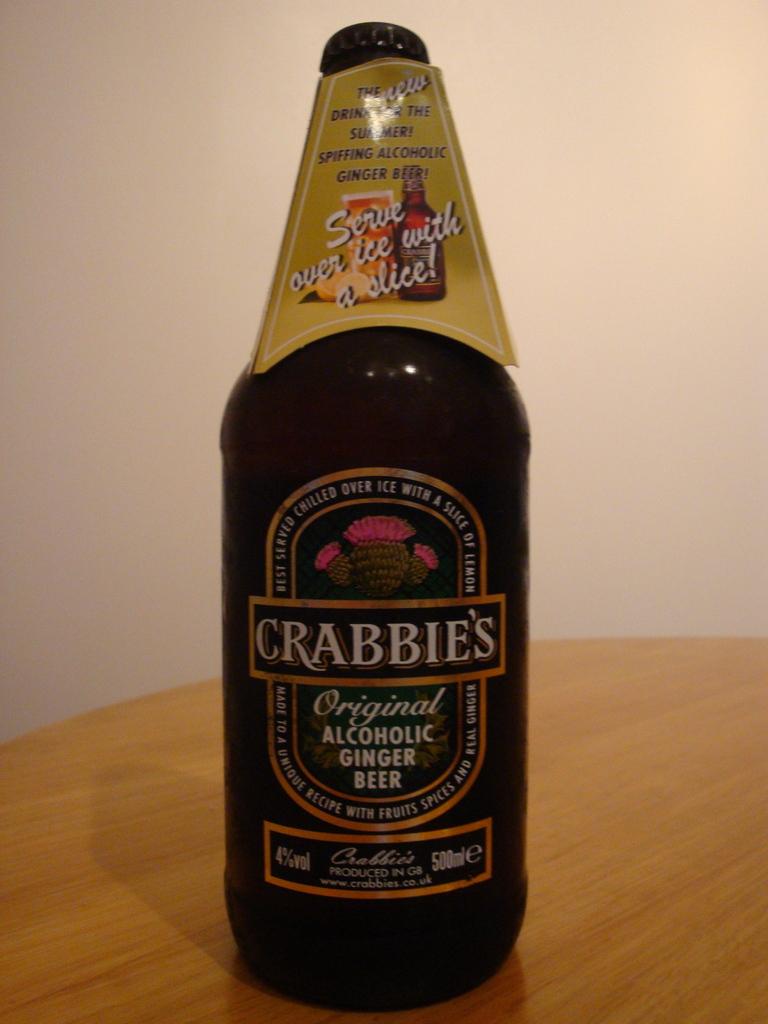Is this a bottle of crabbies?
Provide a succinct answer. Yes. What is the name of this drink?
Offer a terse response. Crabbie's. 